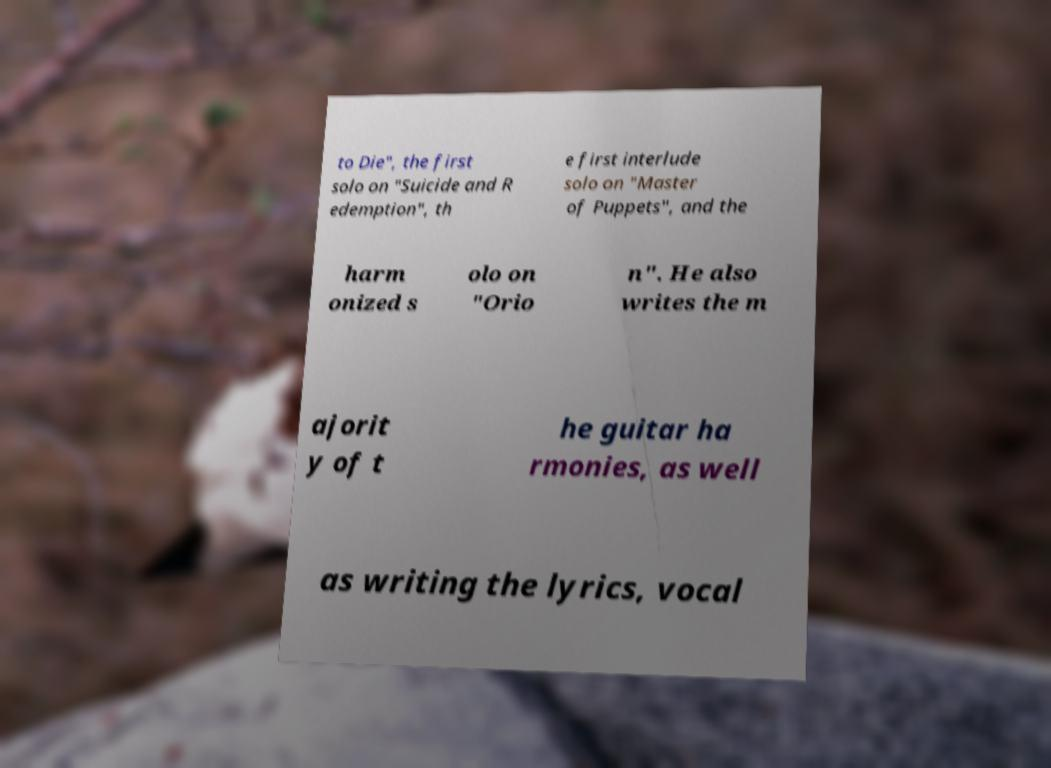Please read and relay the text visible in this image. What does it say? to Die", the first solo on "Suicide and R edemption", th e first interlude solo on "Master of Puppets", and the harm onized s olo on "Orio n". He also writes the m ajorit y of t he guitar ha rmonies, as well as writing the lyrics, vocal 